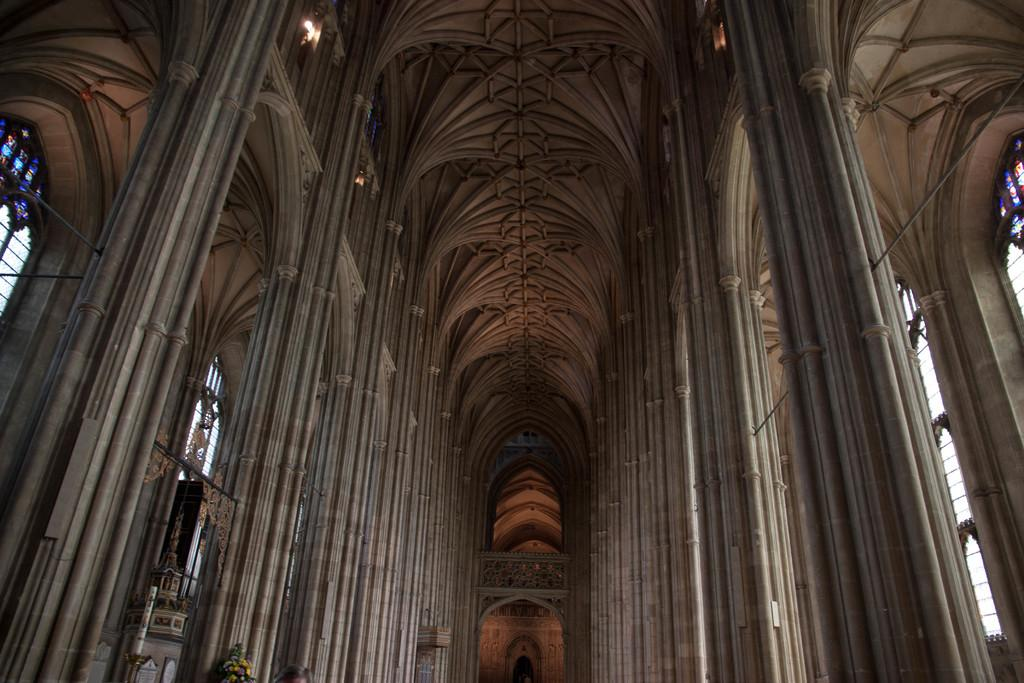What type of location is depicted in the image? The image shows the inside of a building. What architectural features can be seen in the image? There are pillars, windows, arches, and lights visible in the image. What type of power source is used to operate the lights in the image? The image does not provide information about the power source for the lights. Is there a net visible in the image? No, there is no net present in the image. 